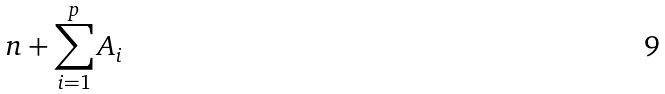<formula> <loc_0><loc_0><loc_500><loc_500>n + \sum _ { i = 1 } ^ { p } A _ { i }</formula> 